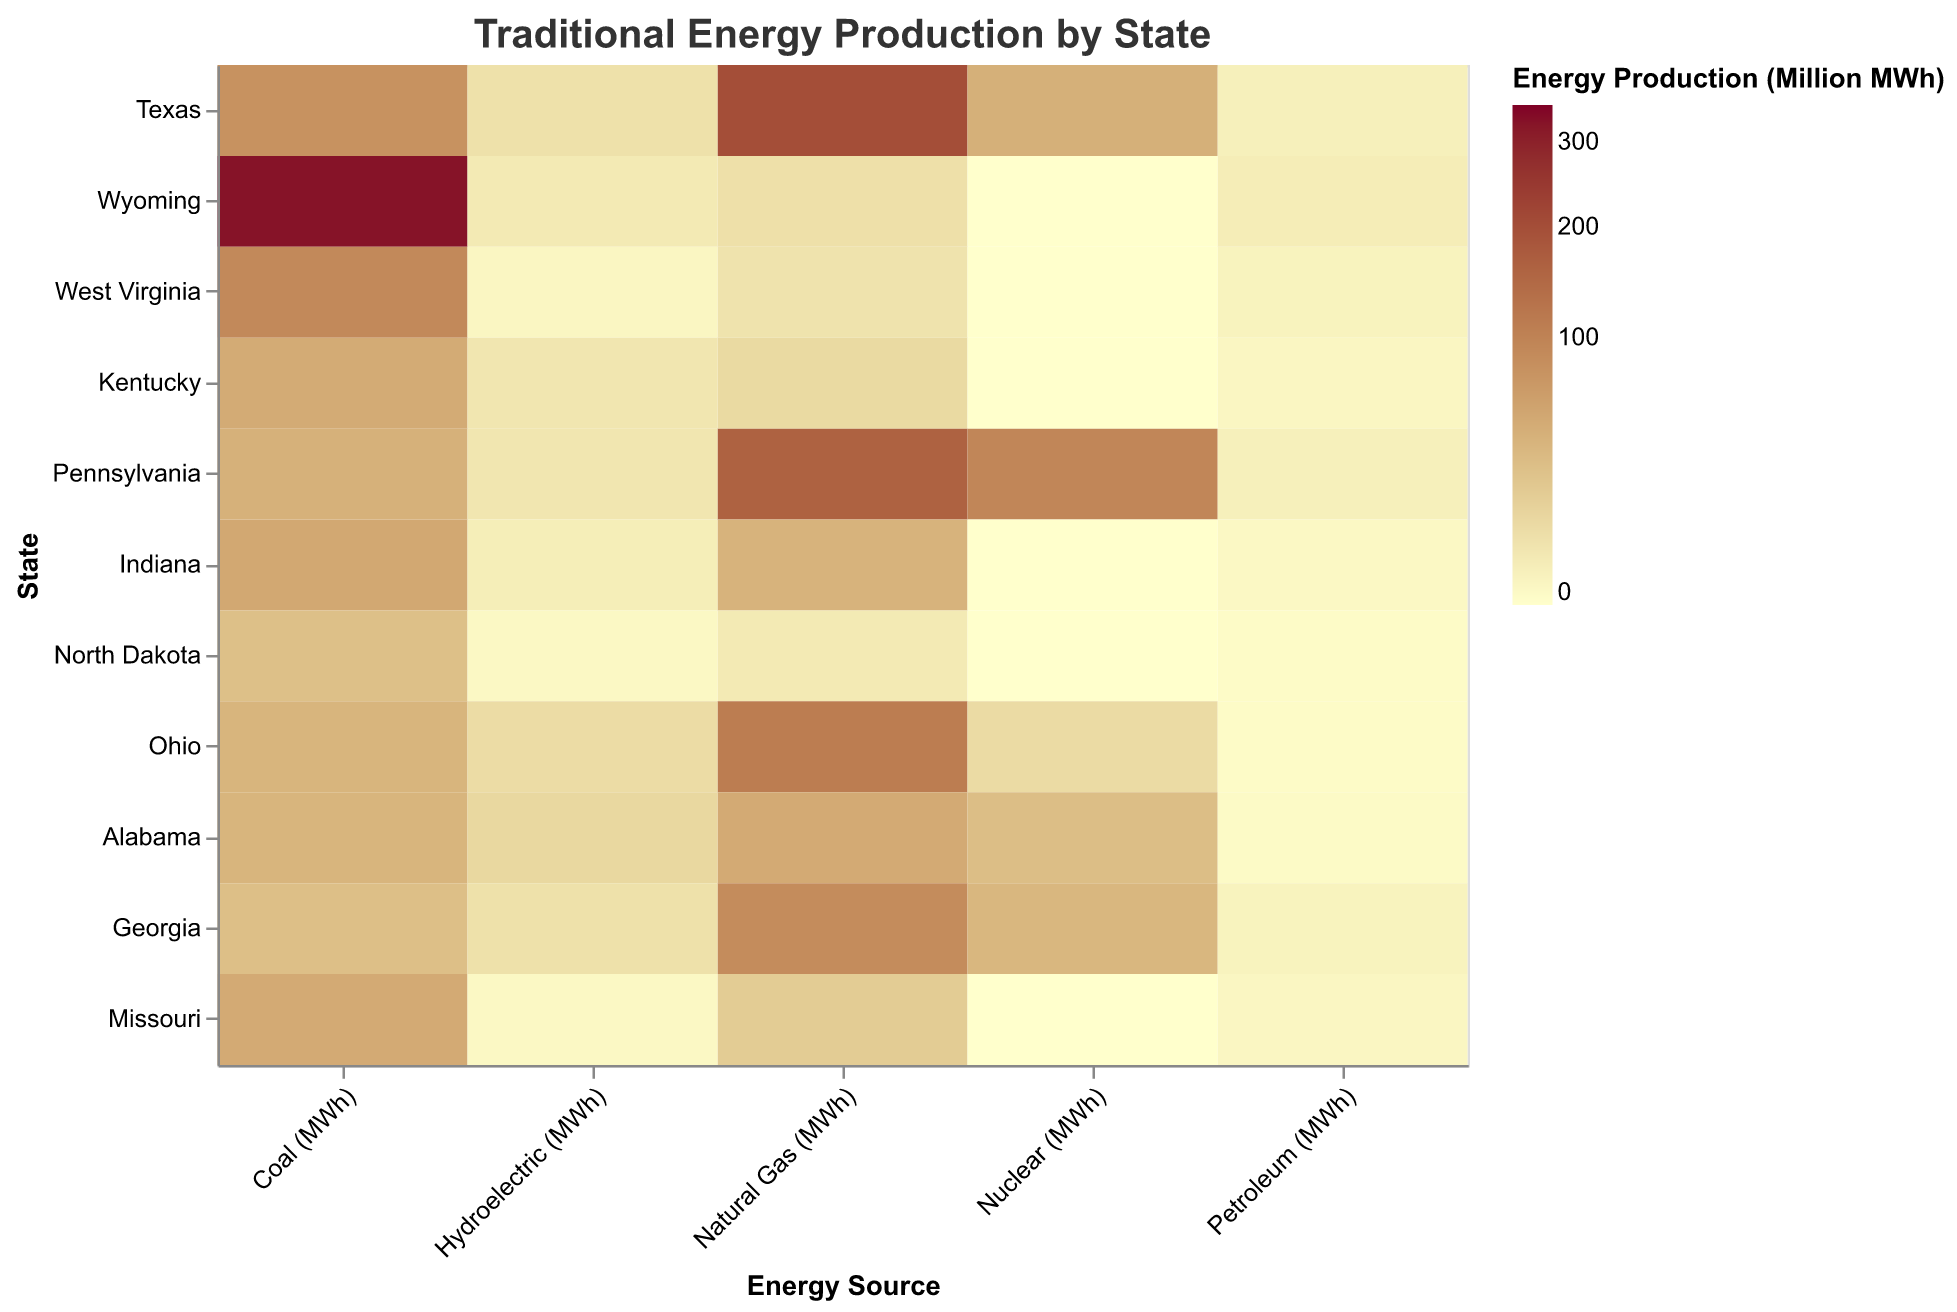What is the state with the highest coal production? The state with the deepest color in the 'Coal (MWh)' column indicates the highest production. Wyoming has the darkest color.
Answer: Wyoming Which state produces the most natural gas? The darkest tile in the 'Natural Gas (MWh)' column represents the highest production. Texas' tile is the deepest color in this column.
Answer: Texas What's the total hydroelectric production of Kentucky and Ohio? Sum the hydroelectric production of both states, Kentucky's is 4 million MWh and Ohio's is 8 million MWh, resulting in 12 million MWh overall.
Answer: 12 million MWh How does Pennsylvania's nuclear production compare to Alabama's? Compare the colors of the tiles in the 'Nuclear (MWh)' column for both states. Pennsylvania's tile is darker, indicating higher nuclear production than Alabama.
Answer: Pennsylvania produces more Which state has the least petroleum production? Look for the lightest colored tile in the 'Petroleum (MWh)' column: North Dakota's tile is the lightest.
Answer: North Dakota What is the average coal production across all states? Divide the total coal production by the number of states. The sum of coal production is (78 + 326 + 90 + 46 + 40 + 49 + 26 + 36 + 36 + 27 + 47) million MWh, which equals 825 million MWh. Dividing by 11 states gives approximately 75 million MWh.
Answer: 75 million MWh What is the difference between Alabama's and Georgia's natural gas production? Subtract Georgia's natural gas production (86 million MWh) from Alabama's (47 million MWh). The difference is 86 - 47 = 39 million MWh.
Answer: 39 million MWh Which state has the highest total energy production from traditional sources? Sum the values across all categories for each state and compare. Wyoming's coal production is significantly high, dominating its total production.
Answer: Wyoming How many states produce zero nuclear energy? Count the states with zero values in the 'Nuclear (MWh)' column. Wyoming, West Virginia, Kentucky, Indiana, North Dakota, and Missouri produce zero nuclear energy.
Answer: Six states Which energy source has the most variability in production across states? Observe the range of colors in each column. The 'Coal (MWh)' column has the most diverse color range, indicating the highest variability.
Answer: Coal 